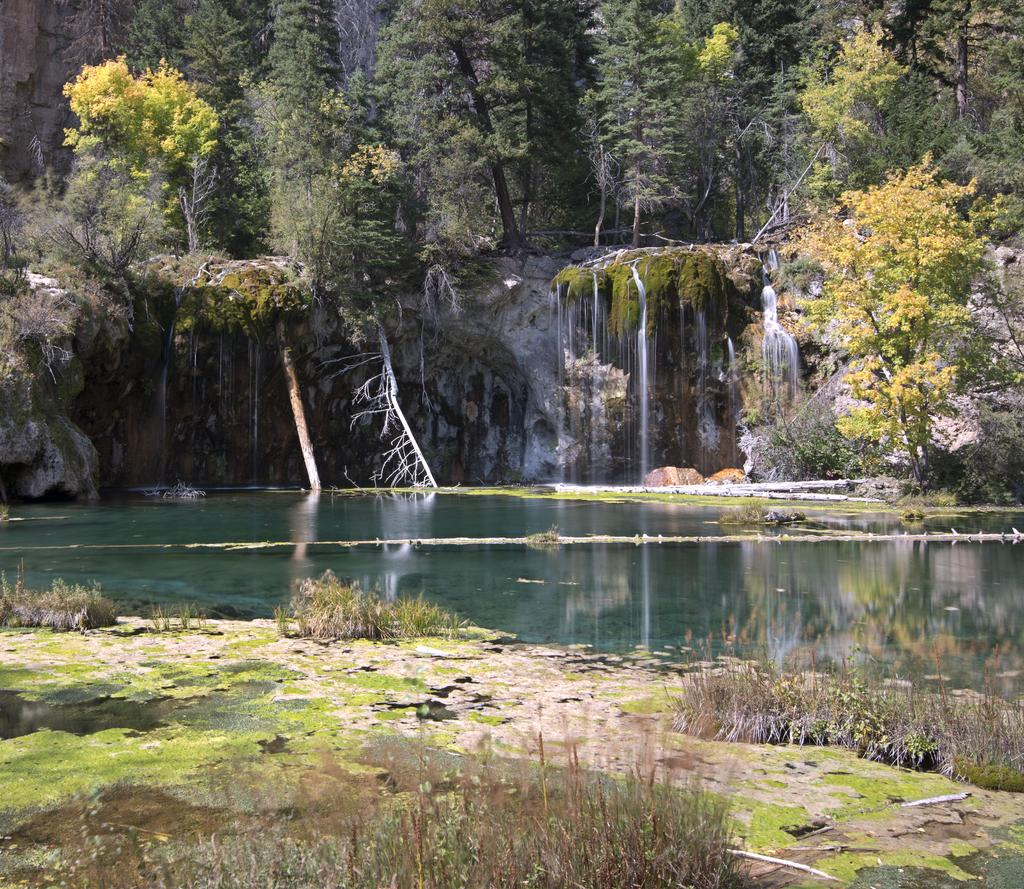What is the main feature in the center of the image? There is a lake in the center of the image. What can be seen in the background of the image? There are trees and a waterfall in the background of the image. What type of vegetation is at the bottom of the image? There is grass at the bottom of the image. How many pizzas are being served by the rock in the image? There are no pizzas or rocks present in the image. What type of pipe can be seen connecting the waterfall to the lake in the image? There is no pipe connecting the waterfall to the lake in the image. 